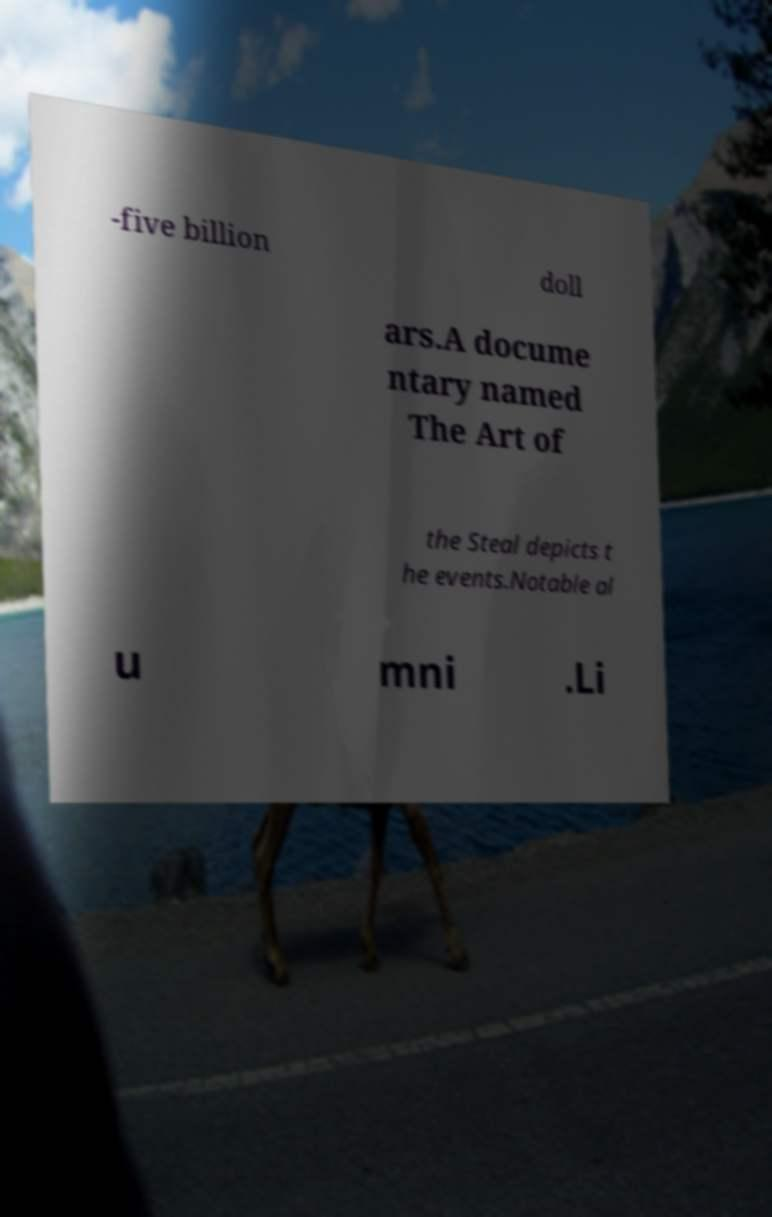I need the written content from this picture converted into text. Can you do that? -five billion doll ars.A docume ntary named The Art of the Steal depicts t he events.Notable al u mni .Li 